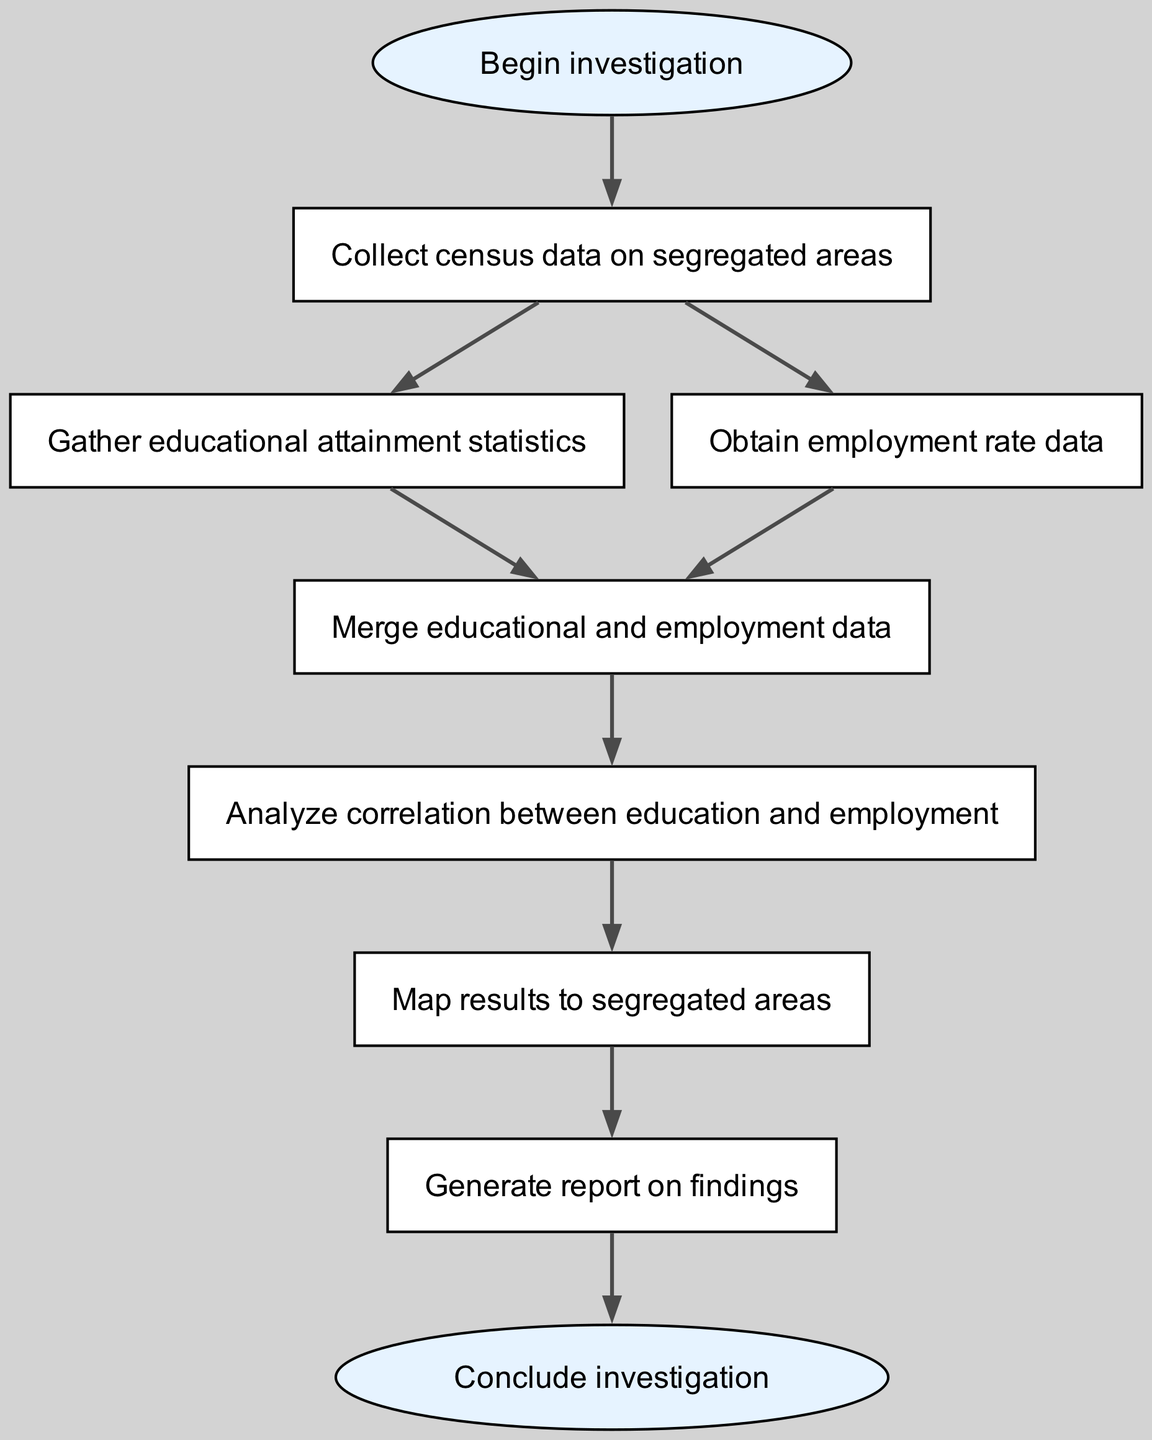What is the first step in the investigation? The diagram starts with the "Begin investigation" node, which indicates that this is the initial action in the process.
Answer: Begin investigation How many nodes are there in the diagram? Counting all the unique process steps shown in the diagram, there are a total of 9 nodes that represent different stages of the investigation.
Answer: 9 Which nodes are connected directly to the "data_collection" node? The "data_collection" node has two direct connections: one to "education_data" and another to "employment_data." This shows the avenues for collecting related data.
Answer: education_data, employment_data What is the final output of the investigation process? The last step in the flowchart is represented by the "Conclude investigation" node, indicating that this marks the end of the investigation process.
Answer: Conclude investigation Which step follows the "Mapping" node? After the "Mapping" node, the next step in the diagram is "Generate report on findings," indicating that results are synthesized into a report after mapping.
Answer: Generate report on findings What type of data is to be obtained after collecting data on segregated areas? The diagram specifies that the next node after data collection involves "Obtain employment rate data," indicating the specific data type to be gathered following the initial collection.
Answer: Obtain employment rate data Which two nodes feed into the "data_merge" node? The "data_merge" node has two inputs: "Gather educational attainment statistics" and "Obtain employment rate data." This means that both data sets are combined at this stage.
Answer: Gather educational attainment statistics, Obtain employment rate data What is the main objective of the "analysis" step? The "Analyze correlation between education and employment" node aims to determine the relationship between educational attainment and employment rates in the examined segregated areas.
Answer: Analyze correlation between education and employment 